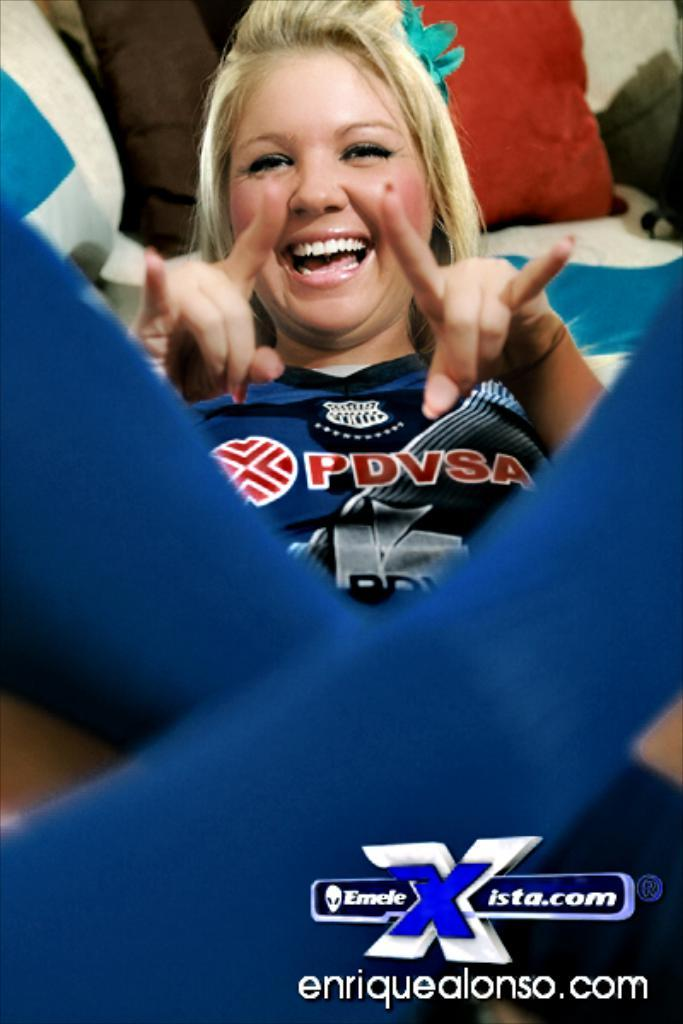<image>
Write a terse but informative summary of the picture. A photo of a blond with enriquealonso.com in the corner of it. 